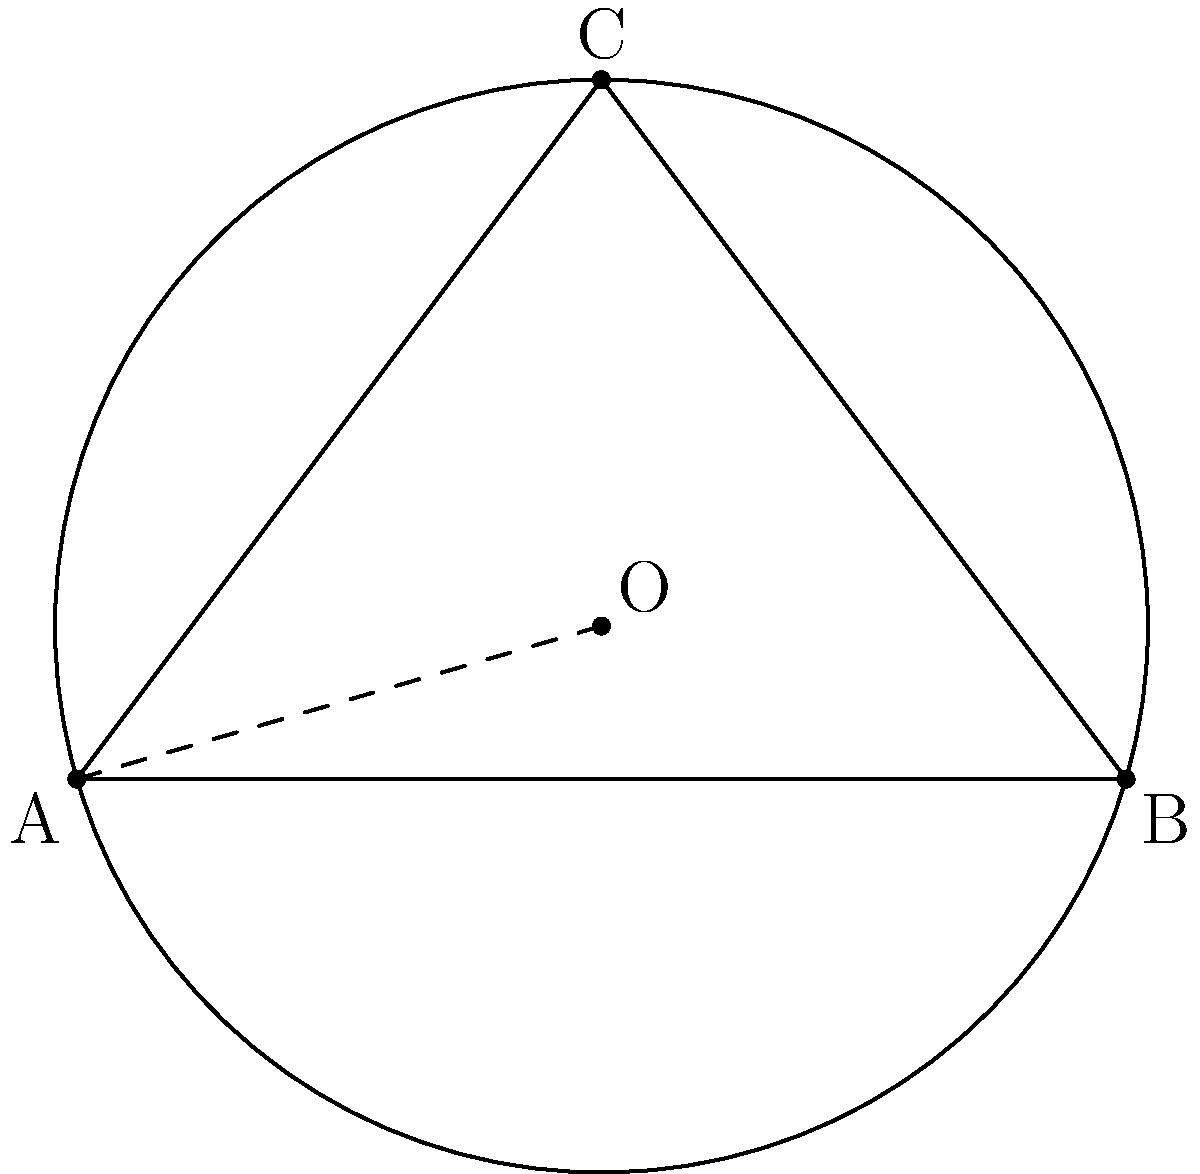In the global marketplace, precision in communication is crucial. Consider a circle passing through three points A(0,0), B(6,0), and C(3,4) on a Cartesian plane. Determine the coordinates of the center (h,k) and the radius r of this circle. Express your answer in the most concise form, as it would be expected in international business communications. To solve this problem efficiently, we'll use the following steps:

1) The center of the circle is the circumcenter of triangle ABC. We can find it using the perpendicular bisector method.

2) Midpoint of AB: $M_1(\frac{0+6}{2}, \frac{0+0}{2}) = (3,0)$
   Midpoint of BC: $M_2(\frac{6+3}{2}, \frac{0+4}{2}) = (4.5,2)$

3) Slope of AB: $m_{AB} = \frac{0-0}{6-0} = 0$
   Perpendicular slope: $m_1 = -\frac{1}{0} = \text{undefined (vertical line)}$

   Slope of BC: $m_{BC} = \frac{4-0}{3-6} = -\frac{4}{3}$
   Perpendicular slope: $m_2 = \frac{3}{4}$

4) Equation of perpendicular bisector of AB: $x = 3$
   Equation of perpendicular bisector of BC: $y - 2 = \frac{3}{4}(x - 4.5)$

5) Solve these equations simultaneously to find the center (h,k):
   $h = 3$
   $k - 2 = \frac{3}{4}(3 - 4.5) = -\frac{9}{8}$
   $k = 2 - \frac{9}{8} = \frac{7}{8}$

6) The center is $(3, \frac{7}{8})$

7) To find the radius, calculate the distance from the center to any of the given points:
   $r = \sqrt{(3-0)^2 + (\frac{7}{8}-0)^2} = \sqrt{9 + \frac{49}{64}} = \sqrt{\frac{625}{64}} = \frac{25}{8}$

Therefore, the center is $(3, \frac{7}{8})$ and the radius is $\frac{25}{8}$.
Answer: Center: $(3, \frac{7}{8})$, Radius: $\frac{25}{8}$ 